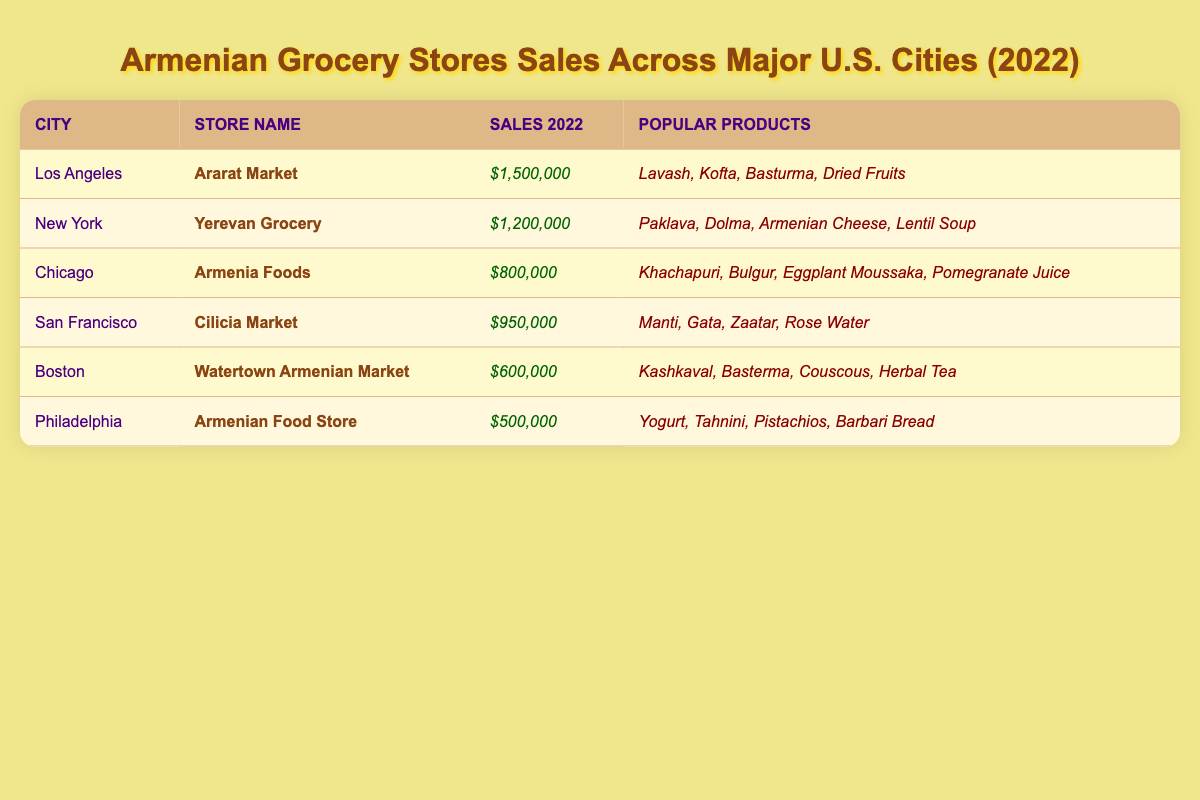What was the highest sales figure among the stores listed? By reviewing the sales figures, the highest amount is $1,500,000 from Ararat Market in Los Angeles.
Answer: $1,500,000 Which city has the store with the lowest sales figure? Upon comparing the sales figures, Philadelphia has the lowest with $500,000.
Answer: Philadelphia How many stores had sales of over $1,000,000? There are 2 stores (Ararat Market in Los Angeles and Yerevan Grocery in New York) that had sales over $1,000,000.
Answer: 2 What are the total sales figures for all stores combined? Adding all sales: $1,500,000 + $1,200,000 + $800,000 + $950,000 + $600,000 + $500,000 = $5,600,000.
Answer: $5,600,000 Is there a store that sold Khachapuri? Yes, Armenia Foods in Chicago sells Khachapuri.
Answer: Yes What are the average sales figures of the stores in San Francisco and Boston? San Francisco's sales are $950,000 and Boston's are $600,000. The average is ($950,000 + $600,000) / 2 = $775,000.
Answer: $775,000 Which store sold the most diverse range of products? Ararat Market in Los Angeles has 4 different products listed, the same as other stores, but they have popular items like Lavash and Kofta which may appeal to a broader audience.
Answer: Ararat Market If you combine the sales figures of New York and Chicago, what would that total be? The sales for New York (Yerevan Grocery) are $1,200,000 and for Chicago (Armenia Foods) are $800,000. Adding these gives $1,200,000 + $800,000 = $2,000,000.
Answer: $2,000,000 Are there any stores in this dataset that made less than $600,000 in sales? Yes, the Armenian Food Store in Philadelphia made $500,000, which is less than $600,000.
Answer: Yes What is the total amount sold by stores in cities that start with a "C"? The cities starting with "C" are Chicago and San Francisco, with corresponding sales of $800,000 and $950,000. Adding these gives $800,000 + $950,000 = $1,750,000.
Answer: $1,750,000 